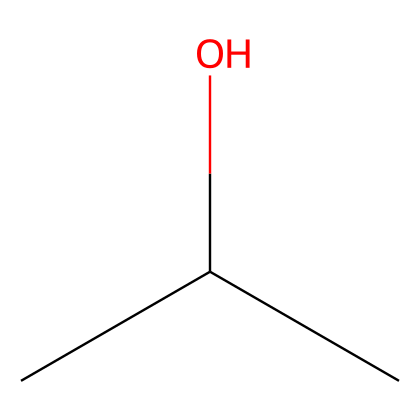What is the chemical name of the compound represented by this SMILES? The SMILES representation "CC(C)O" translates to isopropyl alcohol, which is the common name for this compound.
Answer: isopropyl alcohol How many carbon atoms are present in this structure? By analyzing the SMILES, "CC(C)O" indicates that there are three "C" atoms, showing that there are three carbon atoms in the molecule.
Answer: three How many hydrogens are connected to the carbon atoms in this molecule? The molecular structure suggests that each of the three carbon atoms is bound to hydrogen atoms: the first and second carbons are connected to three hydrogens each, while the central carbon is connected to only one hydrogen due to the alcohol group. Thus, the total hydrogen count is seven.
Answer: seven What functional group is present in isopropyl alcohol? The "O" in the SMILES signifies the presence of a hydroxyl group (-OH), which denotes that this compound is an alcohol.
Answer: hydroxyl Is isopropyl alcohol considered a flammable liquid? Isopropyl alcohol is classified as a flammable liquid due to its low flash point, indicating it can easily ignite at room temperature if exposed to an open flame or spark.
Answer: yes What is the boiling point range of isopropyl alcohol? Isopropyl alcohol typically has a boiling point around 82-83 degrees Celsius, which is characteristic of many flammable liquids.
Answer: 82-83 degrees Celsius How does the structure of isopropyl alcohol influence its flammability? The presence of an alcohol functional group and the overall hydrocarbon structure with several carbon and hydrogen atoms allows it to easily vaporize and mix with air, which increases its flammability.
Answer: it allows easy vaporization and air mixing 